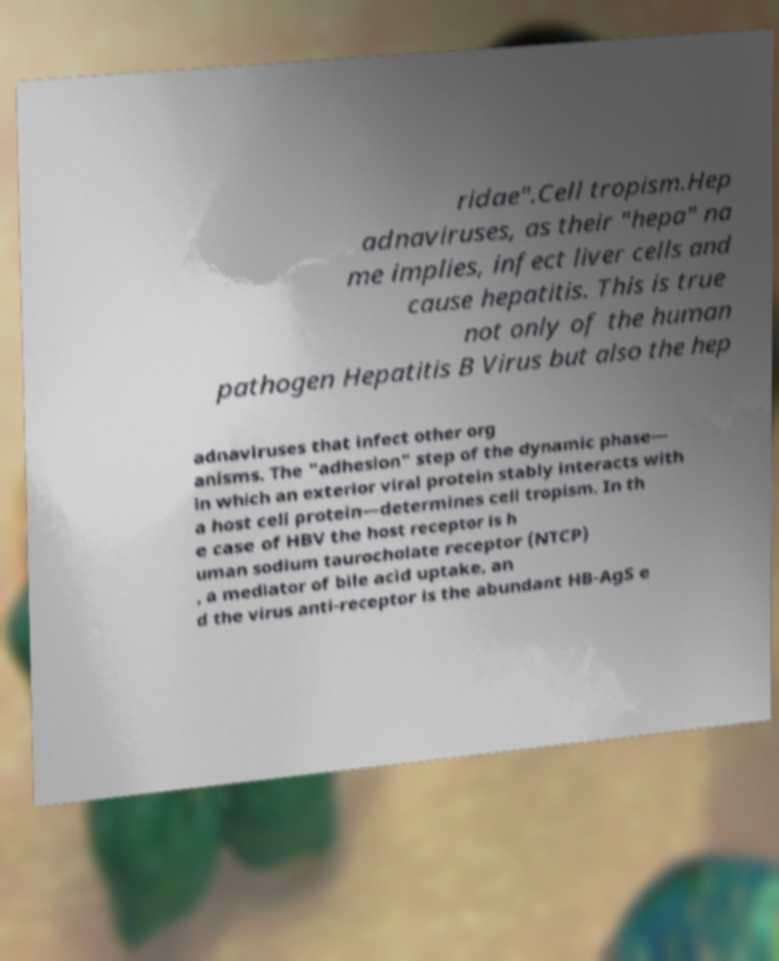Please read and relay the text visible in this image. What does it say? ridae".Cell tropism.Hep adnaviruses, as their "hepa" na me implies, infect liver cells and cause hepatitis. This is true not only of the human pathogen Hepatitis B Virus but also the hep adnaviruses that infect other org anisms. The "adhesion" step of the dynamic phase— in which an exterior viral protein stably interacts with a host cell protein—determines cell tropism. In th e case of HBV the host receptor is h uman sodium taurocholate receptor (NTCP) , a mediator of bile acid uptake, an d the virus anti-receptor is the abundant HB-AgS e 